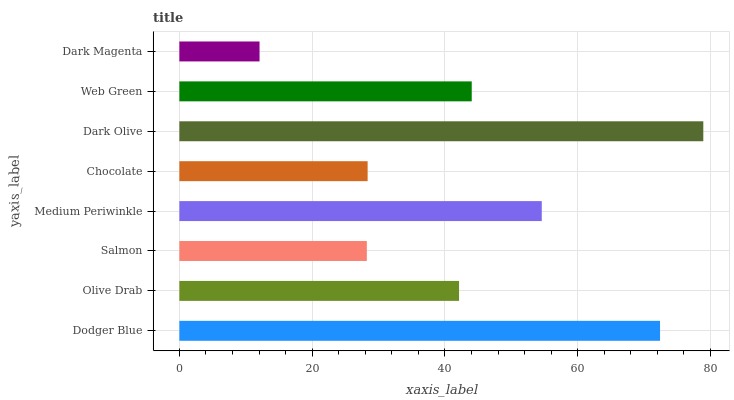Is Dark Magenta the minimum?
Answer yes or no. Yes. Is Dark Olive the maximum?
Answer yes or no. Yes. Is Olive Drab the minimum?
Answer yes or no. No. Is Olive Drab the maximum?
Answer yes or no. No. Is Dodger Blue greater than Olive Drab?
Answer yes or no. Yes. Is Olive Drab less than Dodger Blue?
Answer yes or no. Yes. Is Olive Drab greater than Dodger Blue?
Answer yes or no. No. Is Dodger Blue less than Olive Drab?
Answer yes or no. No. Is Web Green the high median?
Answer yes or no. Yes. Is Olive Drab the low median?
Answer yes or no. Yes. Is Dark Olive the high median?
Answer yes or no. No. Is Salmon the low median?
Answer yes or no. No. 